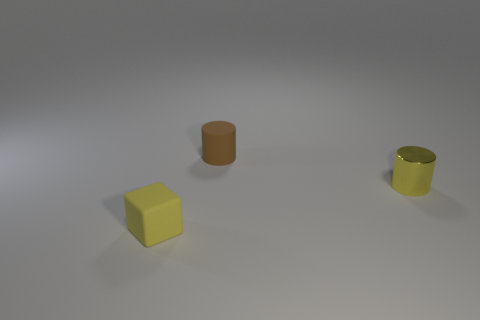Are there any shadows in the image that suggest a light source? Yes, there are shadows cast by all three objects, indicating that there's at least one light source in the scene coming from the upper right direction relative to the perspective of the viewer. The shadows help to add depth and realism to the image. 